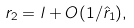Convert formula to latex. <formula><loc_0><loc_0><loc_500><loc_500>r _ { 2 } = l + O ( 1 / \hat { r } _ { 1 } ) ,</formula> 